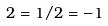<formula> <loc_0><loc_0><loc_500><loc_500>2 = 1 / 2 = - 1</formula> 